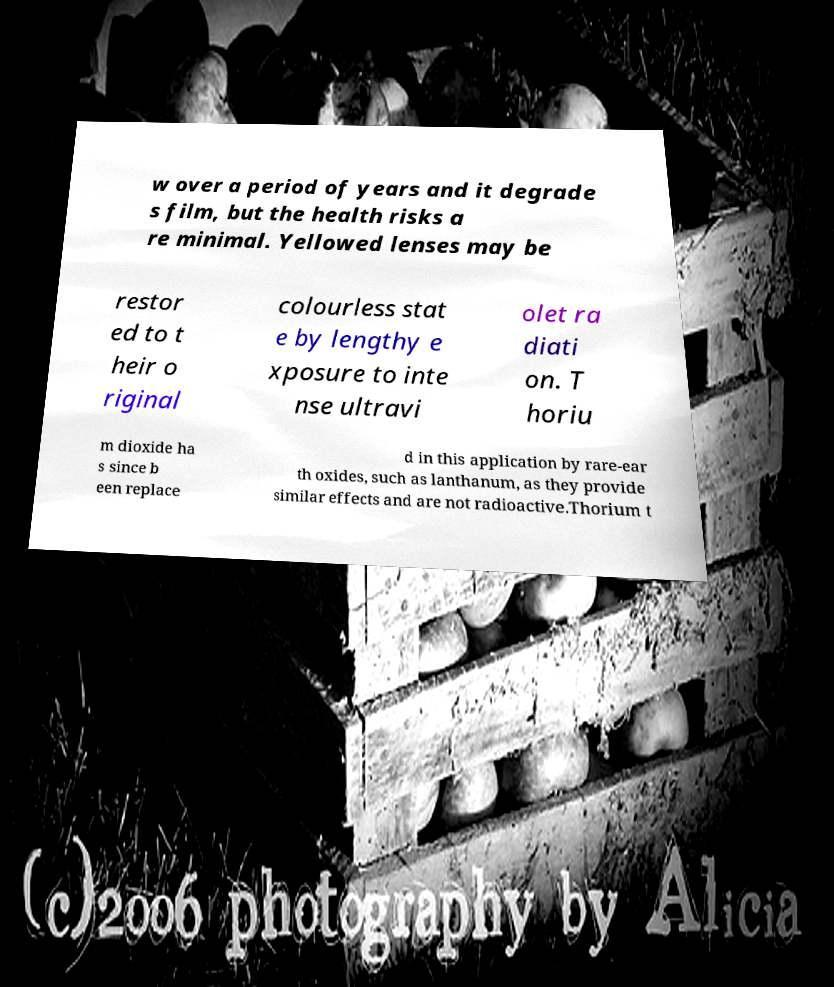Could you extract and type out the text from this image? w over a period of years and it degrade s film, but the health risks a re minimal. Yellowed lenses may be restor ed to t heir o riginal colourless stat e by lengthy e xposure to inte nse ultravi olet ra diati on. T horiu m dioxide ha s since b een replace d in this application by rare-ear th oxides, such as lanthanum, as they provide similar effects and are not radioactive.Thorium t 